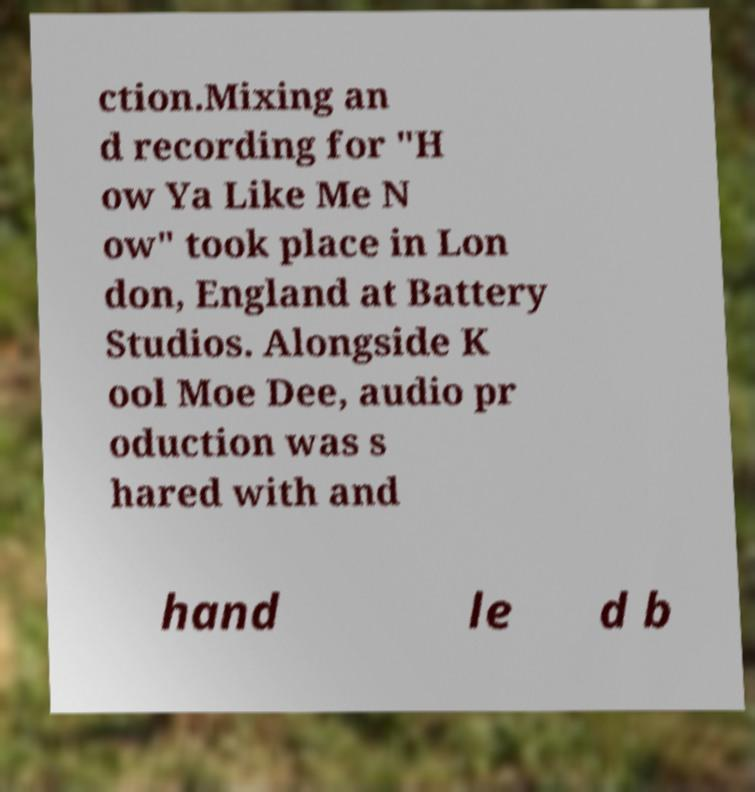Can you accurately transcribe the text from the provided image for me? ction.Mixing an d recording for "H ow Ya Like Me N ow" took place in Lon don, England at Battery Studios. Alongside K ool Moe Dee, audio pr oduction was s hared with and hand le d b 